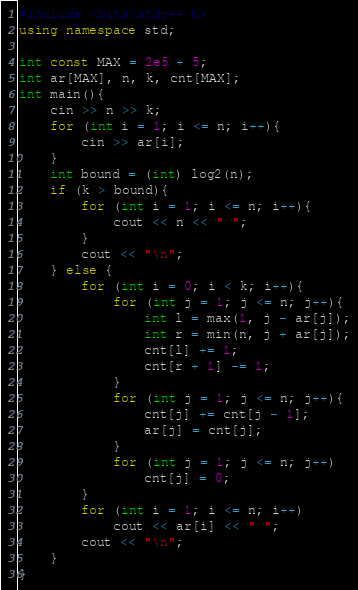Convert code to text. <code><loc_0><loc_0><loc_500><loc_500><_C++_>#include <bits/stdc++.h>
using namespace std;

int const MAX = 2e5 + 5;
int ar[MAX], n, k, cnt[MAX];
int main(){
    cin >> n >> k;
    for (int i = 1; i <= n; i++){
        cin >> ar[i];
    }
    int bound = (int) log2(n);
    if (k > bound){
        for (int i = 1; i <= n; i++){
            cout << n << " ";
        }
        cout << "\n";
    } else {
        for (int i = 0; i < k; i++){
            for (int j = 1; j <= n; j++){
                int l = max(1, j - ar[j]);
                int r = min(n, j + ar[j]);
                cnt[l] += 1;
                cnt[r + 1] -= 1;
            }
            for (int j = 1; j <= n; j++){
                cnt[j] += cnt[j - 1];
                ar[j] = cnt[j];
            }
            for (int j = 1; j <= n; j++)
                cnt[j] = 0;
        }
        for (int i = 1; i <= n; i++)
            cout << ar[i] << " ";
        cout << "\n";
    }
}</code> 